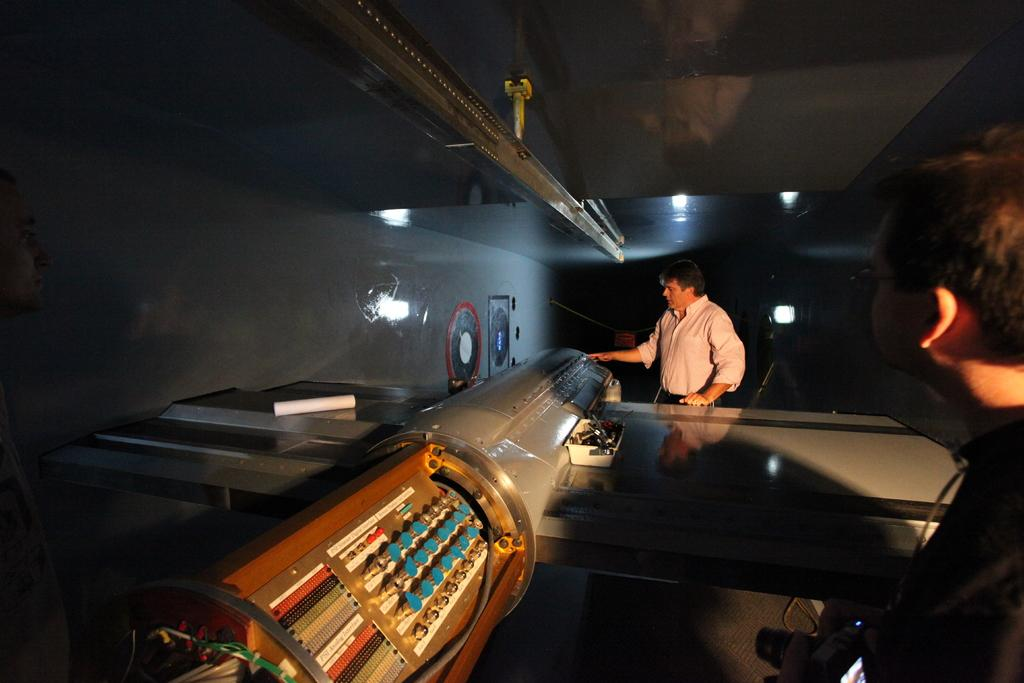What is the main object in the image? There is an electrical machine in the image. Who or what is present on the right side of the image? Two persons are standing on the right side of the image. What can be seen in the background of the image? There is a wall in the background of the image. What type of meat is being prepared by the persons in the image? There is no meat or any indication of food preparation in the image. 